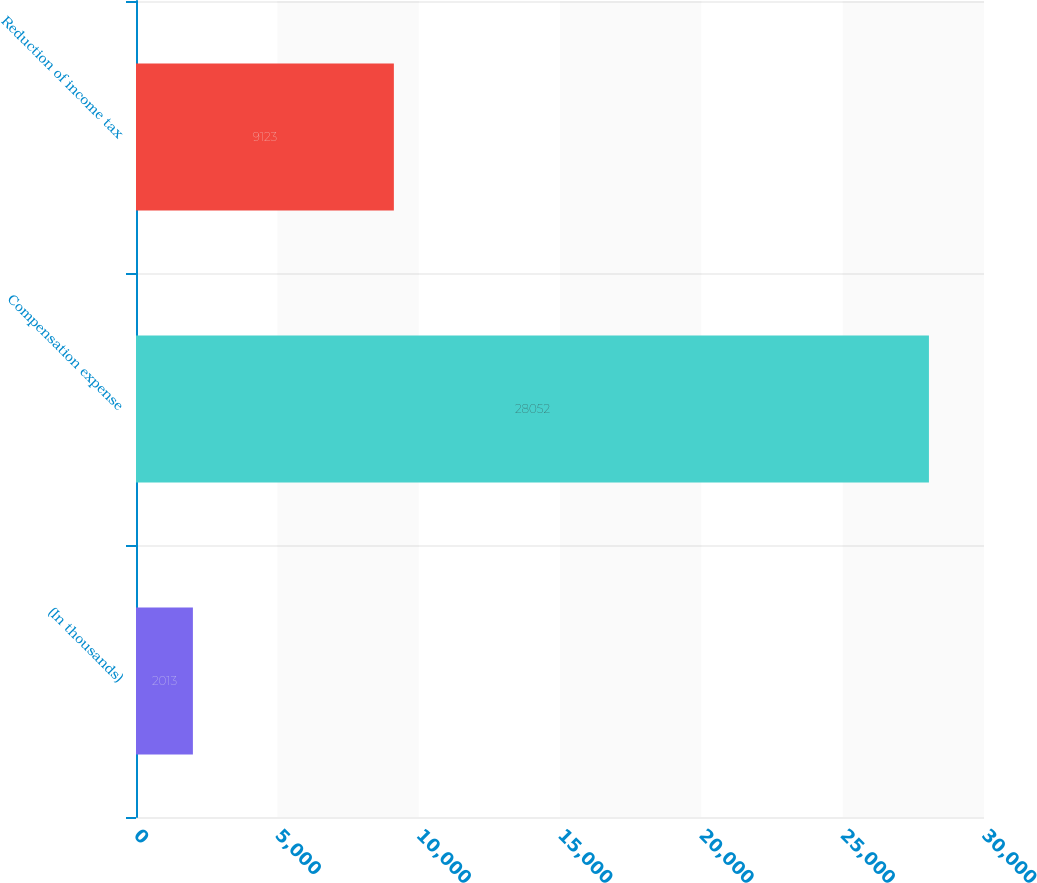Convert chart to OTSL. <chart><loc_0><loc_0><loc_500><loc_500><bar_chart><fcel>(In thousands)<fcel>Compensation expense<fcel>Reduction of income tax<nl><fcel>2013<fcel>28052<fcel>9123<nl></chart> 